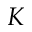<formula> <loc_0><loc_0><loc_500><loc_500>K</formula> 